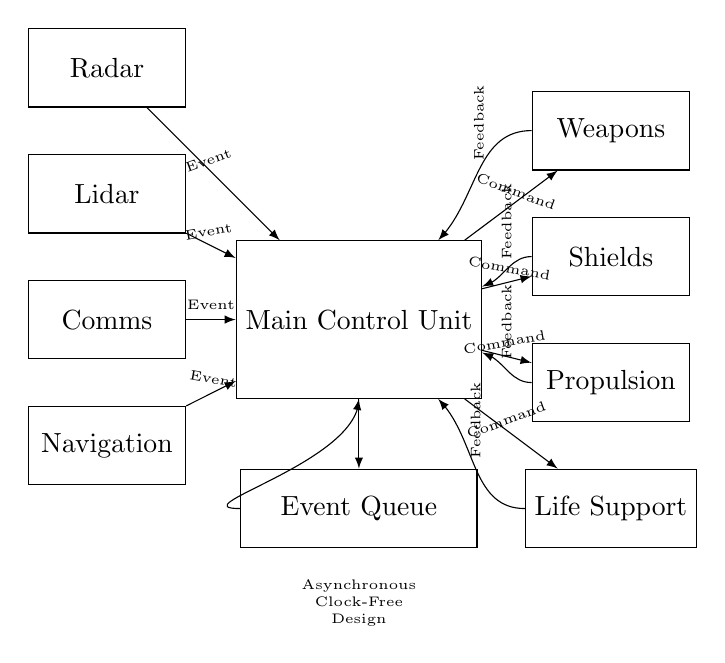What components provide sensor inputs? The sensor inputs in the circuit are provided by Radar, Lidar, Comms, and Navigation. These components are visually represented on the left side of the diagram, indicating that they are sources of information for the Main Control Unit.
Answer: Radar, Lidar, Comms, Navigation What outputs does the Main Control Unit command? The Main Control Unit commands four outputs: Weapons, Shields, Propulsion, and Life Support. These are shown on the right side of the circuit diagram, and arrows are drawn away from the Main Control Unit to these components, indicating command flow.
Answer: Weapons, Shields, Propulsion, Life Support How many sensor inputs are there? There are four sensor inputs: Radar, Lidar, Comms, and Navigation. This is determined by counting the number of rectangle components labeled as sensor inputs on the left side of the diagram.
Answer: Four What type of design is indicated in the circuit? The circuit indicates an Asynchronous Clock-Free design. This is specified at the bottom of the diagram, where it mentions "Asynchronous Clock-Free Design," indicating that the circuit does not rely on a clock signal for operation.
Answer: Asynchronous Clock-Free What represents feedback in this circuit? Feedback is represented by arrows leading from the outputs (Weapons, Shields, Propulsion, and Life Support) back to the Main Control Unit. Each arrow is labeled with "Feedback," showing how the system gathers information about its outputs to inform future commands.
Answer: Feedback arrows Which component has an Event Queue? The Event Queue is a component in the circuit located below the Main Control Unit, indicated by a rectangle labeled "Event Queue." It functions as a storage for events that the Main Control Unit is processing asynchronously.
Answer: Event Queue What is the relationship between sensor inputs and the Main Control Unit? The relationship is asynchronous; the sensor inputs send events to the Main Control Unit, indicated by the arrows labeled "Event" leading from each sensor to the control unit. This shows that the system operates based on the occurrence of events rather than a timed process.
Answer: Asynchronous events 